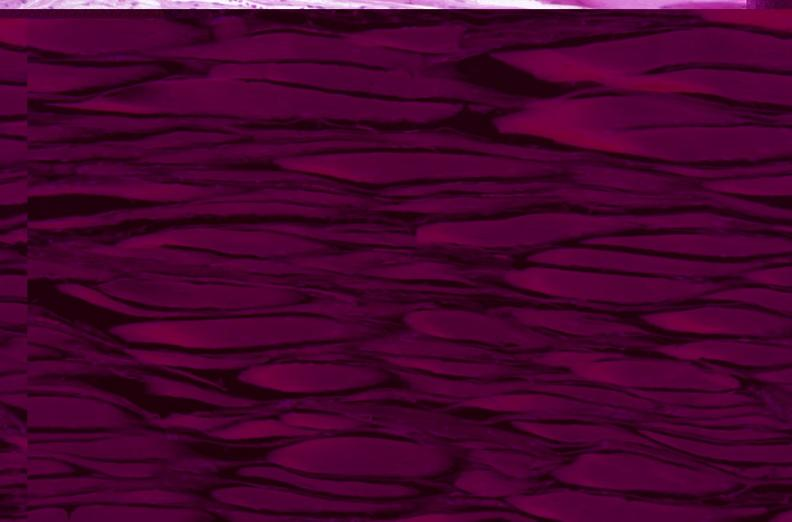s this present?
Answer the question using a single word or phrase. No 